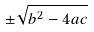<formula> <loc_0><loc_0><loc_500><loc_500>\pm { \sqrt { b ^ { 2 } - 4 a c } }</formula> 